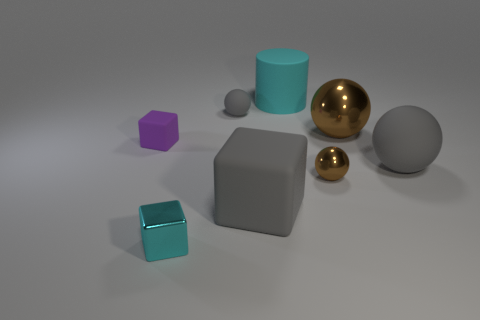Subtract all yellow metal cylinders. Subtract all big matte cylinders. How many objects are left? 7 Add 6 cylinders. How many cylinders are left? 7 Add 8 brown metal things. How many brown metal things exist? 10 Add 2 gray objects. How many objects exist? 10 Subtract all gray matte blocks. How many blocks are left? 2 Subtract 0 red cubes. How many objects are left? 8 Subtract all cubes. How many objects are left? 5 Subtract all green spheres. Subtract all red cylinders. How many spheres are left? 4 Subtract all green cubes. How many gray balls are left? 2 